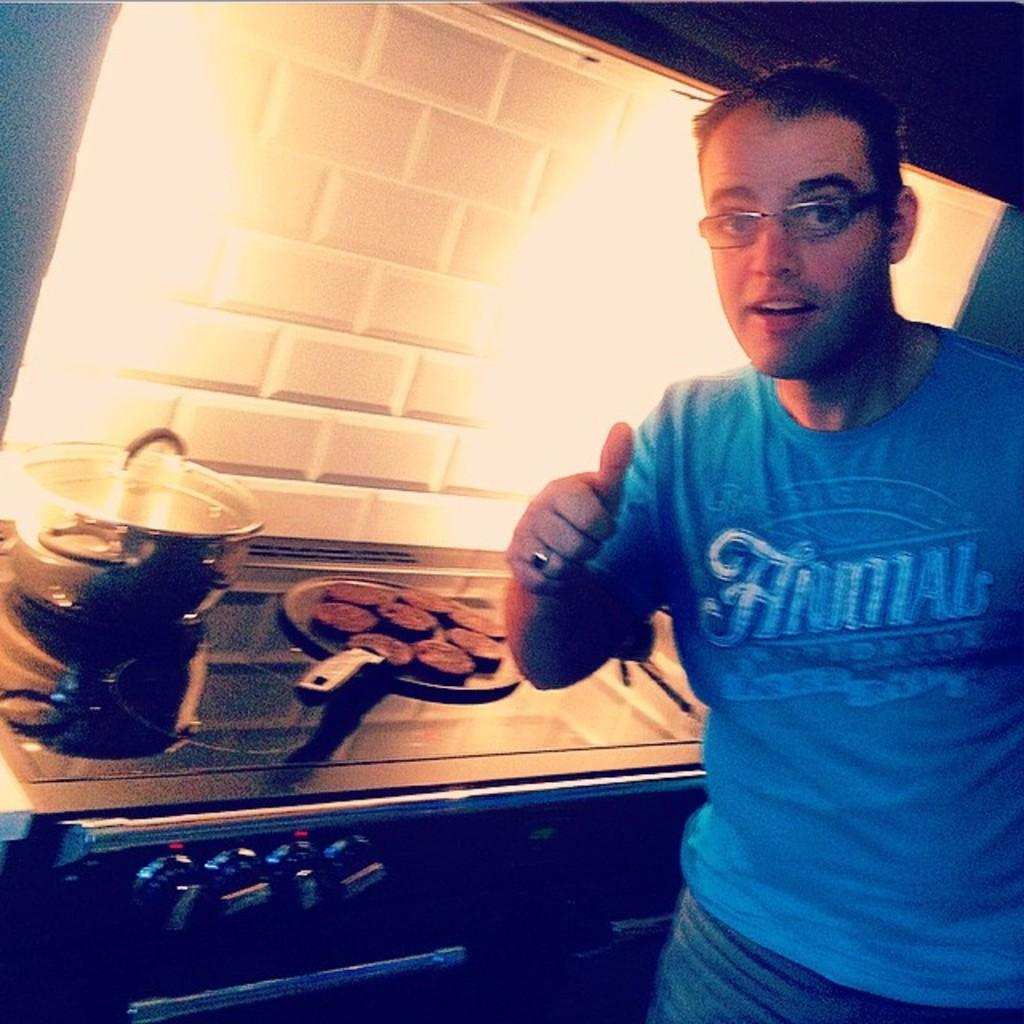<image>
Present a compact description of the photo's key features. a man wearing an 'animal' shirt giving a thumbs up 